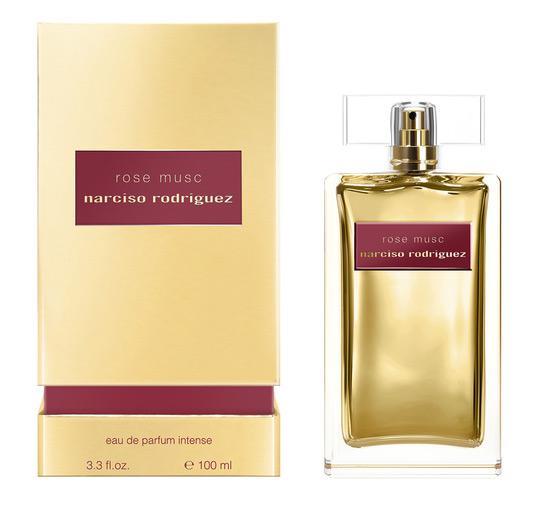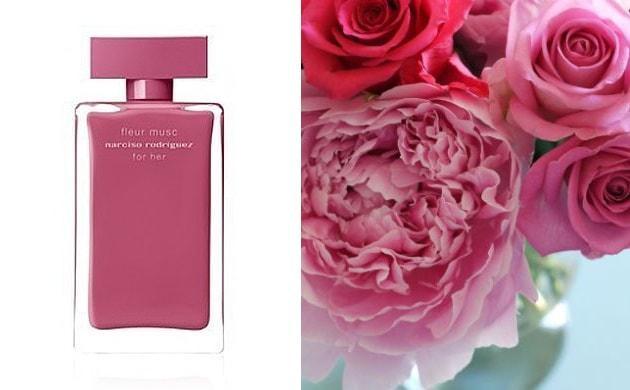The first image is the image on the left, the second image is the image on the right. For the images displayed, is the sentence "There is a visible reflection off the table in one of the images." factually correct? Answer yes or no. No. 